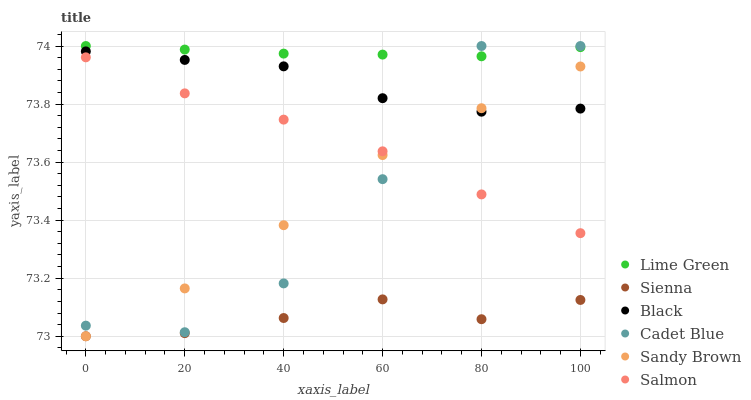Does Sienna have the minimum area under the curve?
Answer yes or no. Yes. Does Lime Green have the maximum area under the curve?
Answer yes or no. Yes. Does Sandy Brown have the minimum area under the curve?
Answer yes or no. No. Does Sandy Brown have the maximum area under the curve?
Answer yes or no. No. Is Lime Green the smoothest?
Answer yes or no. Yes. Is Cadet Blue the roughest?
Answer yes or no. Yes. Is Sandy Brown the smoothest?
Answer yes or no. No. Is Sandy Brown the roughest?
Answer yes or no. No. Does Sandy Brown have the lowest value?
Answer yes or no. Yes. Does Salmon have the lowest value?
Answer yes or no. No. Does Lime Green have the highest value?
Answer yes or no. Yes. Does Sandy Brown have the highest value?
Answer yes or no. No. Is Sienna less than Cadet Blue?
Answer yes or no. Yes. Is Lime Green greater than Black?
Answer yes or no. Yes. Does Sandy Brown intersect Salmon?
Answer yes or no. Yes. Is Sandy Brown less than Salmon?
Answer yes or no. No. Is Sandy Brown greater than Salmon?
Answer yes or no. No. Does Sienna intersect Cadet Blue?
Answer yes or no. No. 